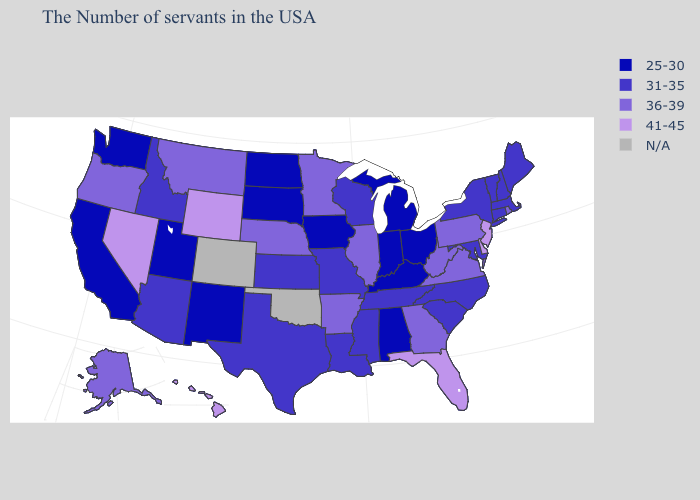Among the states that border Pennsylvania , does Maryland have the lowest value?
Answer briefly. No. What is the value of Arkansas?
Short answer required. 36-39. Among the states that border Arkansas , which have the highest value?
Answer briefly. Tennessee, Mississippi, Louisiana, Missouri, Texas. What is the value of Virginia?
Write a very short answer. 36-39. Does the map have missing data?
Short answer required. Yes. Among the states that border South Carolina , which have the lowest value?
Concise answer only. North Carolina. Name the states that have a value in the range N/A?
Keep it brief. Oklahoma, Colorado. Among the states that border North Dakota , does South Dakota have the highest value?
Write a very short answer. No. Which states hav the highest value in the West?
Short answer required. Wyoming, Nevada, Hawaii. What is the value of Nevada?
Keep it brief. 41-45. What is the lowest value in the Northeast?
Keep it brief. 31-35. Name the states that have a value in the range 31-35?
Answer briefly. Maine, Massachusetts, New Hampshire, Vermont, Connecticut, New York, Maryland, North Carolina, South Carolina, Tennessee, Wisconsin, Mississippi, Louisiana, Missouri, Kansas, Texas, Arizona, Idaho. Among the states that border Ohio , which have the highest value?
Keep it brief. Pennsylvania, West Virginia. Name the states that have a value in the range 25-30?
Answer briefly. Ohio, Michigan, Kentucky, Indiana, Alabama, Iowa, South Dakota, North Dakota, New Mexico, Utah, California, Washington. Which states have the lowest value in the USA?
Be succinct. Ohio, Michigan, Kentucky, Indiana, Alabama, Iowa, South Dakota, North Dakota, New Mexico, Utah, California, Washington. 